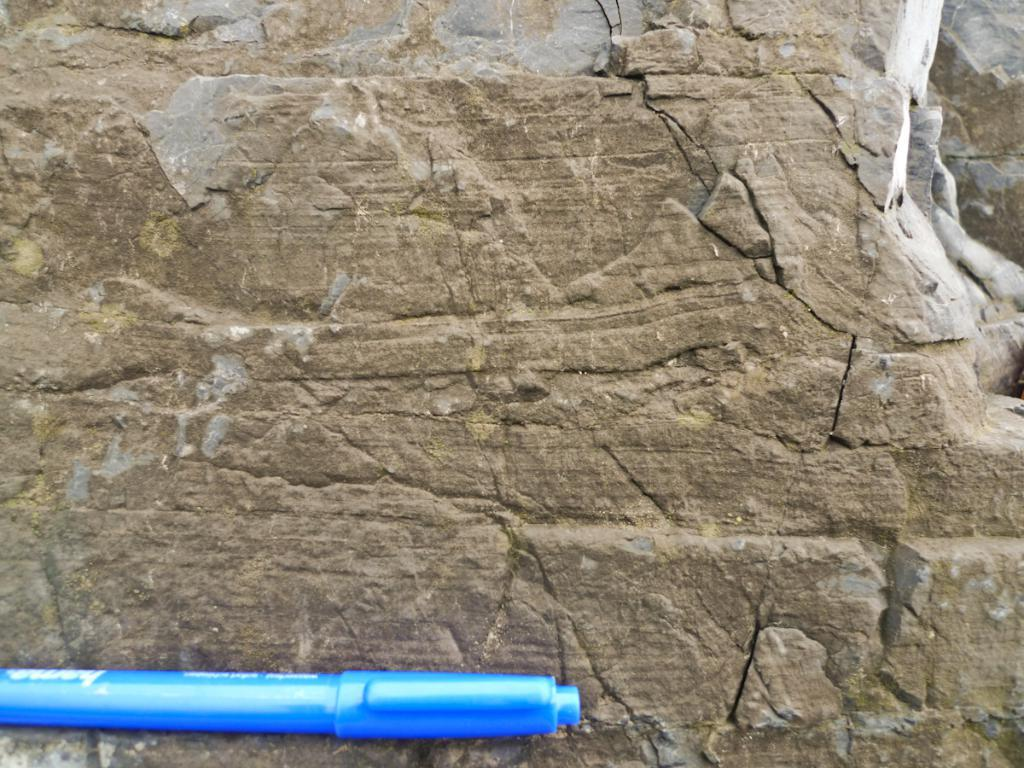What type of writing instrument is in the image? There is a blue color pen in the image. Where is the pen located? The pen is on a rock. What can be found on the pen? There is text on the pen. What type of gold object is attached to the pen in the image? There is no gold object attached to the pen in the image. 